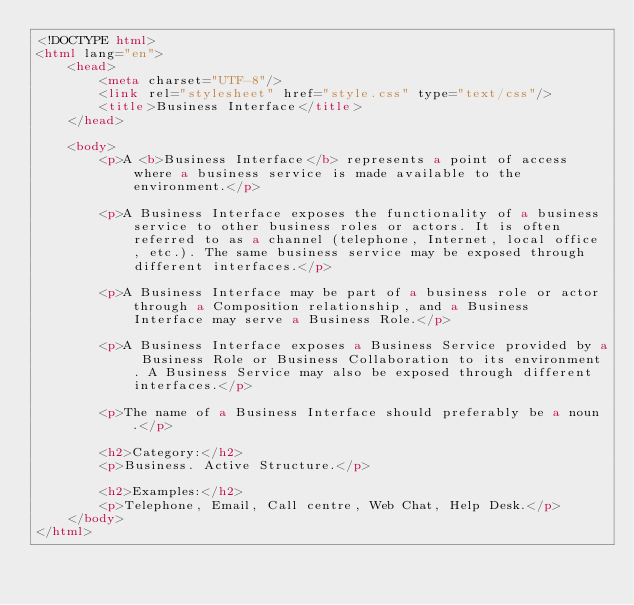<code> <loc_0><loc_0><loc_500><loc_500><_HTML_><!DOCTYPE html>
<html lang="en">
    <head>
        <meta charset="UTF-8"/>
        <link rel="stylesheet" href="style.css" type="text/css"/>
        <title>Business Interface</title>
    </head>
    
    <body>
        <p>A <b>Business Interface</b> represents a point of access where a business service is made available to the environment.</p>
        
        <p>A Business Interface exposes the functionality of a business service to other business roles or actors. It is often referred to as a channel (telephone, Internet, local office, etc.). The same business service may be exposed through different interfaces.</p>
        
        <p>A Business Interface may be part of a business role or actor through a Composition relationship, and a Business Interface may serve a Business Role.</p>
        
        <p>A Business Interface exposes a Business Service provided by a Business Role or Business Collaboration to its environment. A Business Service may also be exposed through different interfaces.</p>
        
        <p>The name of a Business Interface should preferably be a noun.</p>
        
        <h2>Category:</h2>
        <p>Business. Active Structure.</p>
        
        <h2>Examples:</h2>
        <p>Telephone, Email, Call centre, Web Chat, Help Desk.</p>
    </body>
</html>
</code> 